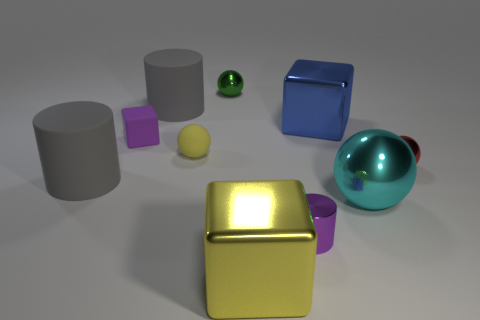Subtract all gray balls. Subtract all brown cylinders. How many balls are left? 4 Subtract all cubes. How many objects are left? 7 Add 6 tiny metallic objects. How many tiny metallic objects exist? 9 Subtract 0 blue cylinders. How many objects are left? 10 Subtract all small green shiny objects. Subtract all gray metal cylinders. How many objects are left? 9 Add 3 tiny matte balls. How many tiny matte balls are left? 4 